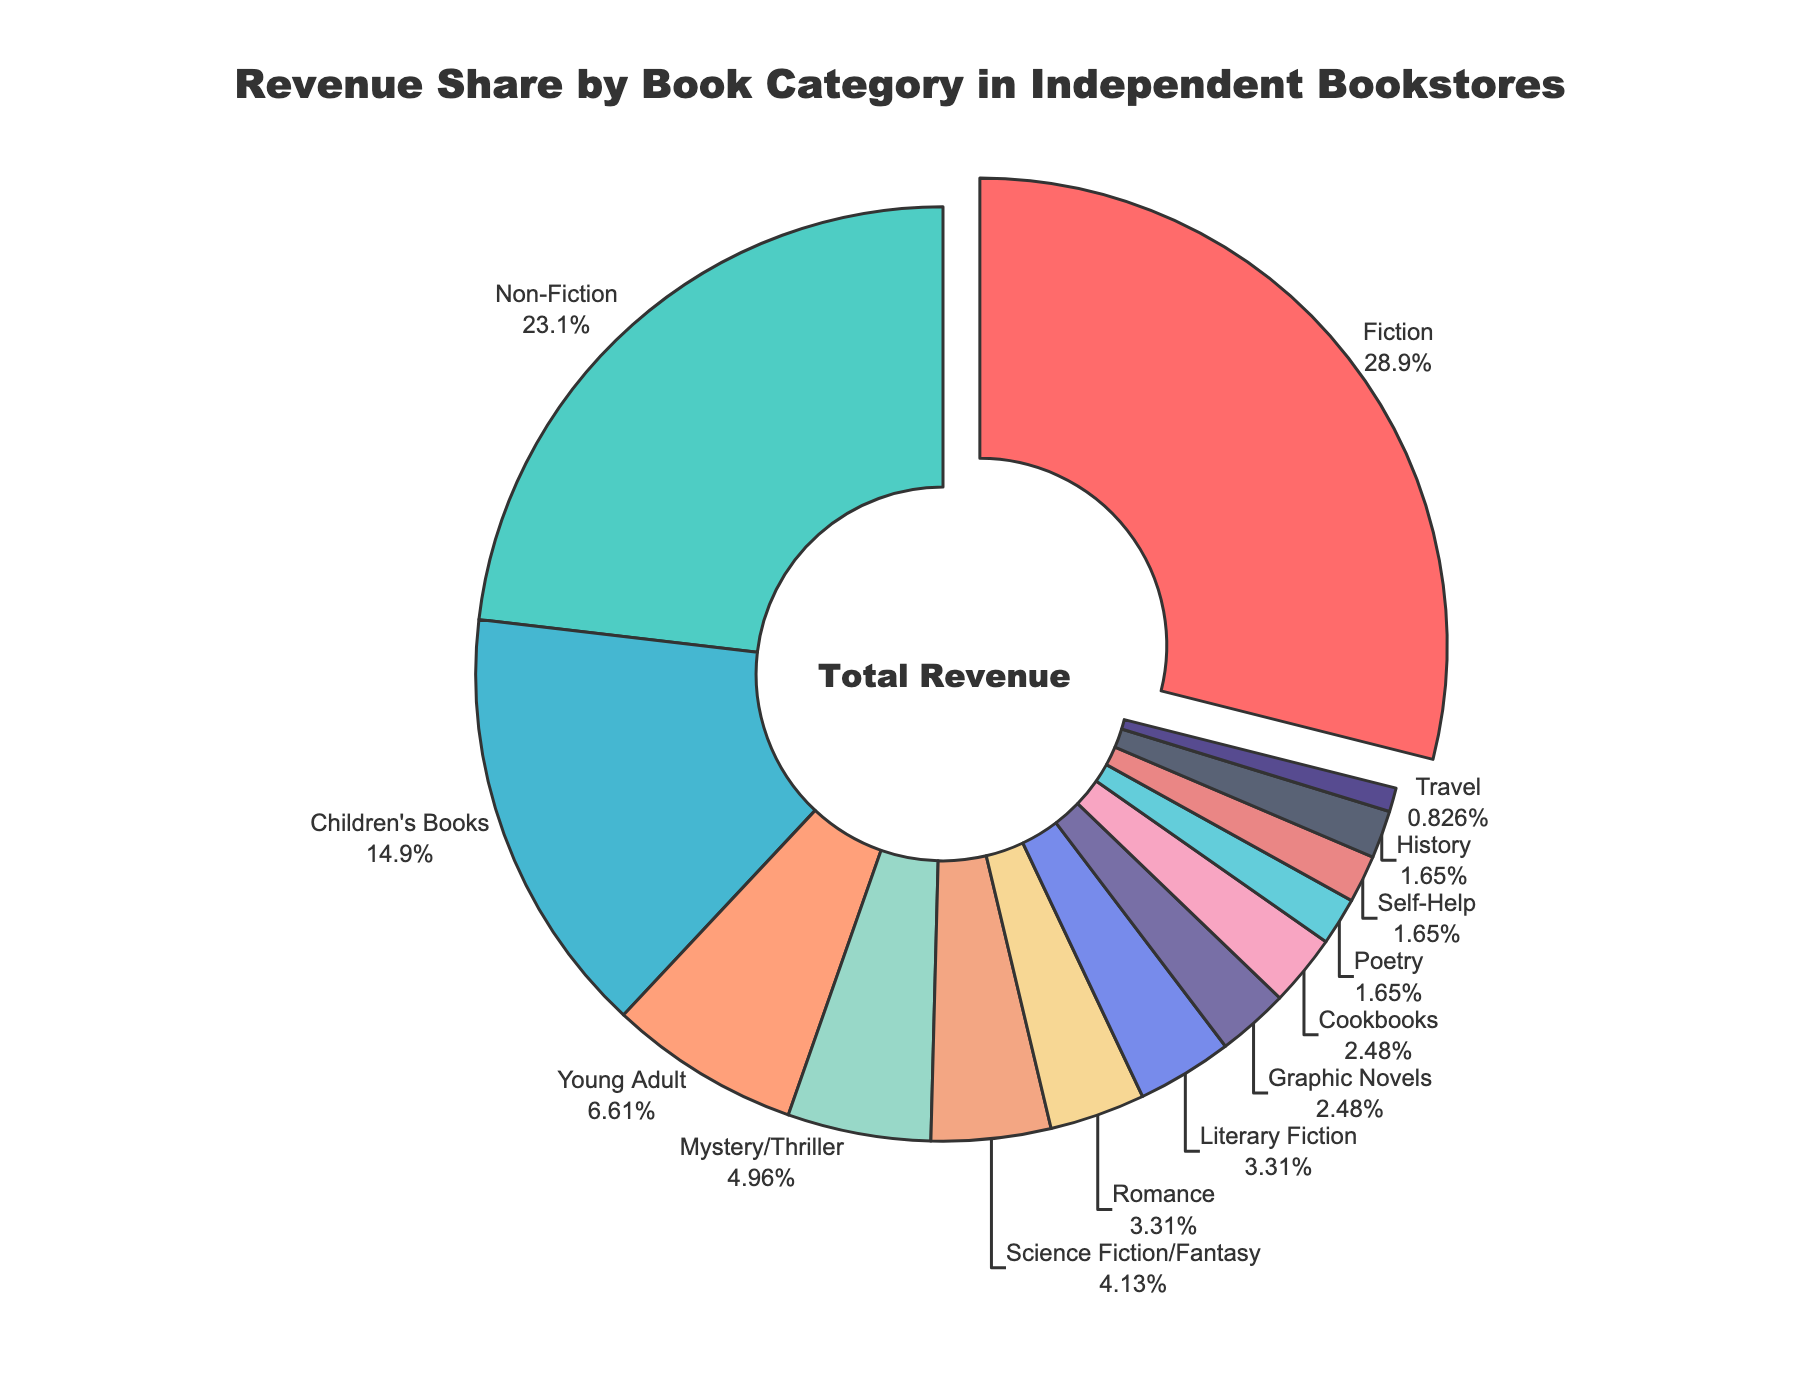What category contributes the highest revenue share? The largest segment in the pie chart represents the highest revenue share. The label for "Fiction" shows the highest percentage.
Answer: Fiction How much more revenue share does Fiction have compared to Non-Fiction? Fiction has 35% and Non-Fiction has 28%. Subtracting these two gives 35% - 28% = 7%.
Answer: 7% Which category has the smallest revenue share? The smallest segment in the pie chart represents the smallest revenue share. The label for "Travel" shows the smallest percentage.
Answer: Travel What is the combined revenue share of Children's Books and Young Adult categories? Children's Books have 18% and Young Adult has 8%. Adding these two gives 18% + 8% = 26%.
Answer: 26% Which category has a higher revenue share: Mystery/Thriller or Science Fiction/Fantasy? Mystery/Thriller has 6% and Science Fiction/Fantasy has 5%. Since 6% > 5%, Mystery/Thriller has a higher revenue share.
Answer: Mystery/Thriller Which categories have a revenue share of less than 5%? The segments with labels showing less than 5% are Science Fiction/Fantasy, Romance, Graphic Novels, Literary Fiction, Poetry, Self-Help, Travel, and History.
Answer: Science Fiction/Fantasy, Romance, Graphic Novels, Literary Fiction, Poetry, Self-Help, Travel, History What is the revenue share difference between Non-Fiction and Young Adult categories? Non-Fiction has 28% and Young Adult has 8%. Subtracting these two gives 28% - 8% = 20%.
Answer: 20% What are two categories next to Fiction in terms of revenue share? The categories with revenue shares closest to Fiction (35%) are Non-Fiction (28%) and Children's Books (18%).
Answer: Non-Fiction, Children's Books What is the total revenue share of all categories that have a share greater than or equal to 10%? The categories with a share >= 10% are Fiction (35%), Non-Fiction (28%), and Children's Books (18%). Summing these gives 35% + 28% + 18% = 81%.
Answer: 81% 